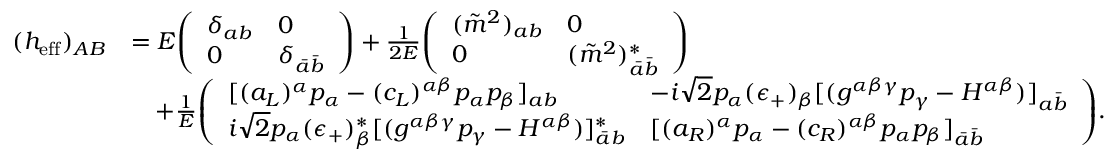<formula> <loc_0><loc_0><loc_500><loc_500>{ \begin{array} { r l } { ( h _ { e f f } ) _ { A B } } & { = E { \left ( \begin{array} { l l } { \delta _ { a b } } & { 0 } \\ { 0 } & { \delta _ { { \bar { a } } { \bar { b } } } } \end{array} \right ) } + { \frac { 1 } { 2 E } } { \left ( \begin{array} { l l } { ( { \tilde { m } } ^ { 2 } ) _ { a b } } & { 0 } \\ { 0 } & { ( { \tilde { m } } ^ { 2 } ) _ { { \bar { a } } { \bar { b } } } ^ { * } } \end{array} \right ) } } \\ & { \quad + { \frac { 1 } { E } } { \left ( \begin{array} { l l } { [ ( a _ { L } ) ^ { \alpha } p _ { \alpha } - ( c _ { L } ) ^ { \alpha \beta } p _ { \alpha } p _ { \beta } ] _ { a b } } & { - i { \sqrt { 2 } } p _ { \alpha } ( \epsilon _ { + } ) _ { \beta } [ ( g ^ { \alpha \beta \gamma } p _ { \gamma } - H ^ { \alpha \beta } ) ] _ { a { \bar { b } } } } \\ { i { \sqrt { 2 } } p _ { \alpha } ( \epsilon _ { + } ) _ { \beta } ^ { * } [ ( g ^ { \alpha \beta \gamma } p _ { \gamma } - H ^ { \alpha \beta } ) ] _ { { \bar { a } } b } ^ { * } } & { [ ( a _ { R } ) ^ { \alpha } p _ { \alpha } - ( c _ { R } ) ^ { \alpha \beta } p _ { \alpha } p _ { \beta } ] _ { { \bar { a } } { \bar { b } } } } \end{array} \right ) } . } \end{array} }</formula> 